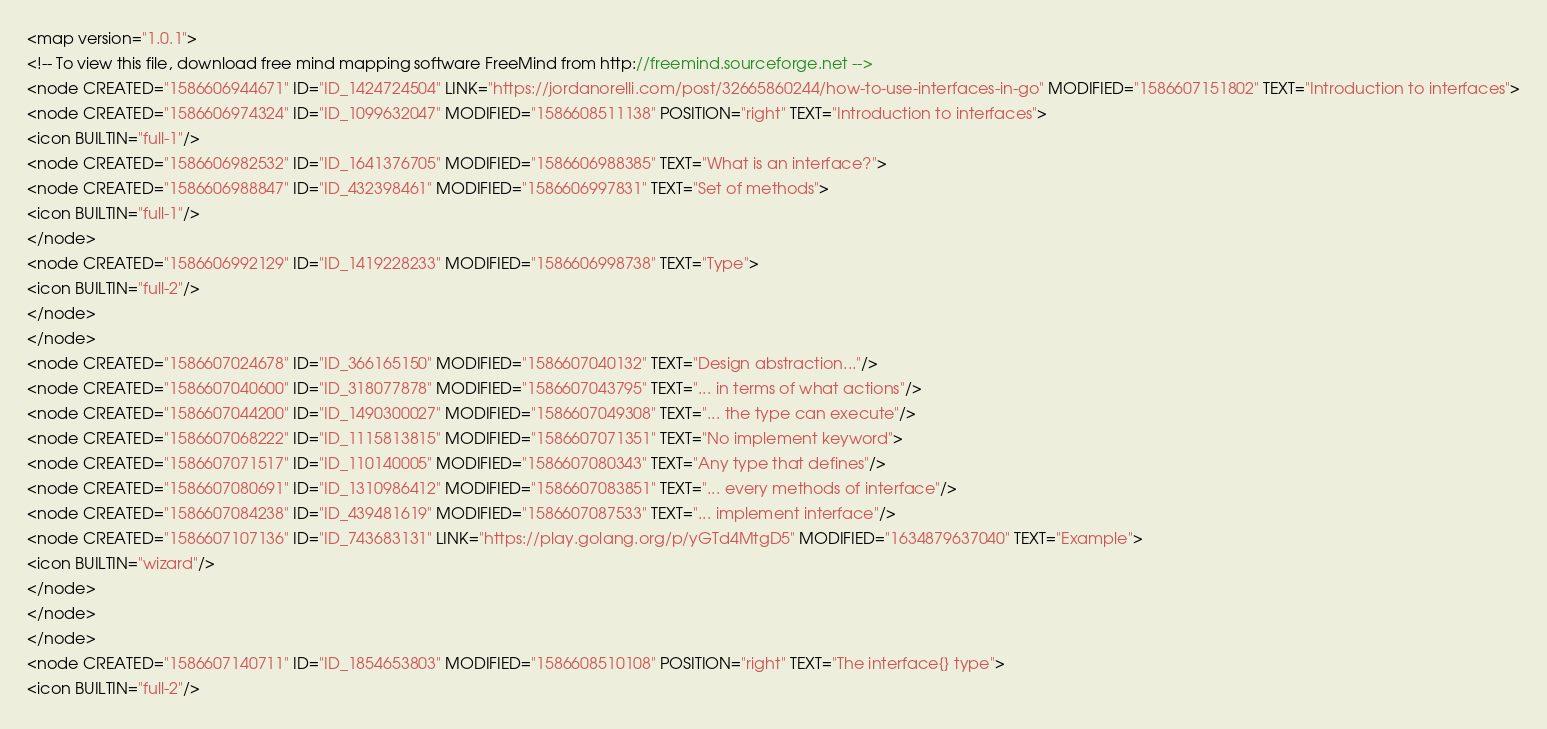Convert code to text. <code><loc_0><loc_0><loc_500><loc_500><_ObjectiveC_><map version="1.0.1">
<!-- To view this file, download free mind mapping software FreeMind from http://freemind.sourceforge.net -->
<node CREATED="1586606944671" ID="ID_1424724504" LINK="https://jordanorelli.com/post/32665860244/how-to-use-interfaces-in-go" MODIFIED="1586607151802" TEXT="Introduction to interfaces">
<node CREATED="1586606974324" ID="ID_1099632047" MODIFIED="1586608511138" POSITION="right" TEXT="Introduction to interfaces">
<icon BUILTIN="full-1"/>
<node CREATED="1586606982532" ID="ID_1641376705" MODIFIED="1586606988385" TEXT="What is an interface?">
<node CREATED="1586606988847" ID="ID_432398461" MODIFIED="1586606997831" TEXT="Set of methods">
<icon BUILTIN="full-1"/>
</node>
<node CREATED="1586606992129" ID="ID_1419228233" MODIFIED="1586606998738" TEXT="Type">
<icon BUILTIN="full-2"/>
</node>
</node>
<node CREATED="1586607024678" ID="ID_366165150" MODIFIED="1586607040132" TEXT="Design abstraction..."/>
<node CREATED="1586607040600" ID="ID_318077878" MODIFIED="1586607043795" TEXT="... in terms of what actions"/>
<node CREATED="1586607044200" ID="ID_1490300027" MODIFIED="1586607049308" TEXT="... the type can execute"/>
<node CREATED="1586607068222" ID="ID_1115813815" MODIFIED="1586607071351" TEXT="No implement keyword">
<node CREATED="1586607071517" ID="ID_110140005" MODIFIED="1586607080343" TEXT="Any type that defines"/>
<node CREATED="1586607080691" ID="ID_1310986412" MODIFIED="1586607083851" TEXT="... every methods of interface"/>
<node CREATED="1586607084238" ID="ID_439481619" MODIFIED="1586607087533" TEXT="... implement interface"/>
<node CREATED="1586607107136" ID="ID_743683131" LINK="https://play.golang.org/p/yGTd4MtgD5" MODIFIED="1634879637040" TEXT="Example">
<icon BUILTIN="wizard"/>
</node>
</node>
</node>
<node CREATED="1586607140711" ID="ID_1854653803" MODIFIED="1586608510108" POSITION="right" TEXT="The interface{} type">
<icon BUILTIN="full-2"/></code> 